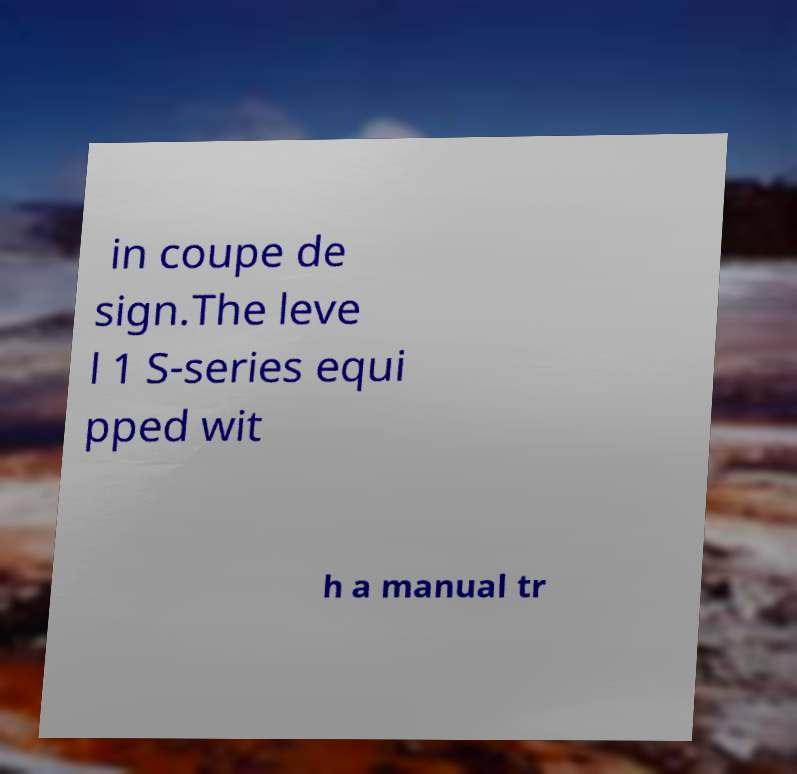Can you read and provide the text displayed in the image?This photo seems to have some interesting text. Can you extract and type it out for me? in coupe de sign.The leve l 1 S-series equi pped wit h a manual tr 